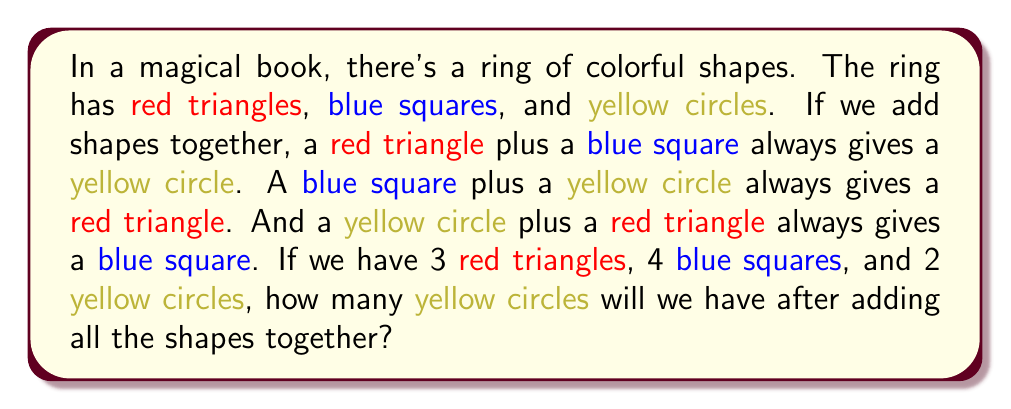What is the answer to this math problem? Let's approach this step-by-step:

1) First, let's define our shapes:
   $R$ = Red triangle
   $B$ = Blue square
   $Y$ = Yellow circle

2) From the given information, we can write:
   $R + B = Y$
   $B + Y = R$
   $Y + R = B$

3) We start with:
   3 Red triangles (3R)
   4 Blue squares (4B)
   2 Yellow circles (2Y)

4) Let's add the red triangles and blue squares first:
   $3R + 4B = 3Y + B$ (because $R + B = Y$)

5) Now we have:
   3Y + B + 2Y

6) Let's add the remaining blue square to a yellow circle:
   $3Y + (B + Y) + Y = 3Y + R + Y$ (because $B + Y = R$)

7) Finally, we have:
   $3Y + R + Y = 3Y + B$ (because $Y + R = B$)

8) Our final result is 3Y + B, which means we end up with 3 yellow circles and 1 blue square.

Therefore, after adding all the shapes together, we will have 3 yellow circles.
Answer: 3 yellow circles 